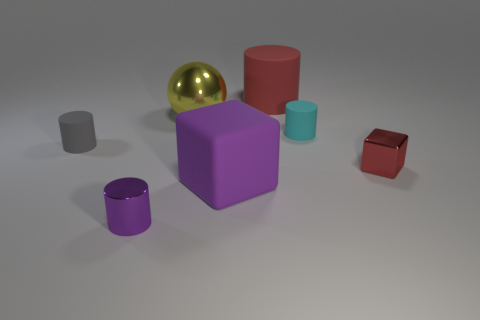Add 3 cubes. How many objects exist? 10 Subtract all balls. How many objects are left? 6 Add 6 big red objects. How many big red objects are left? 7 Add 6 tiny cyan matte things. How many tiny cyan matte things exist? 7 Subtract 0 purple balls. How many objects are left? 7 Subtract all yellow shiny cylinders. Subtract all red things. How many objects are left? 5 